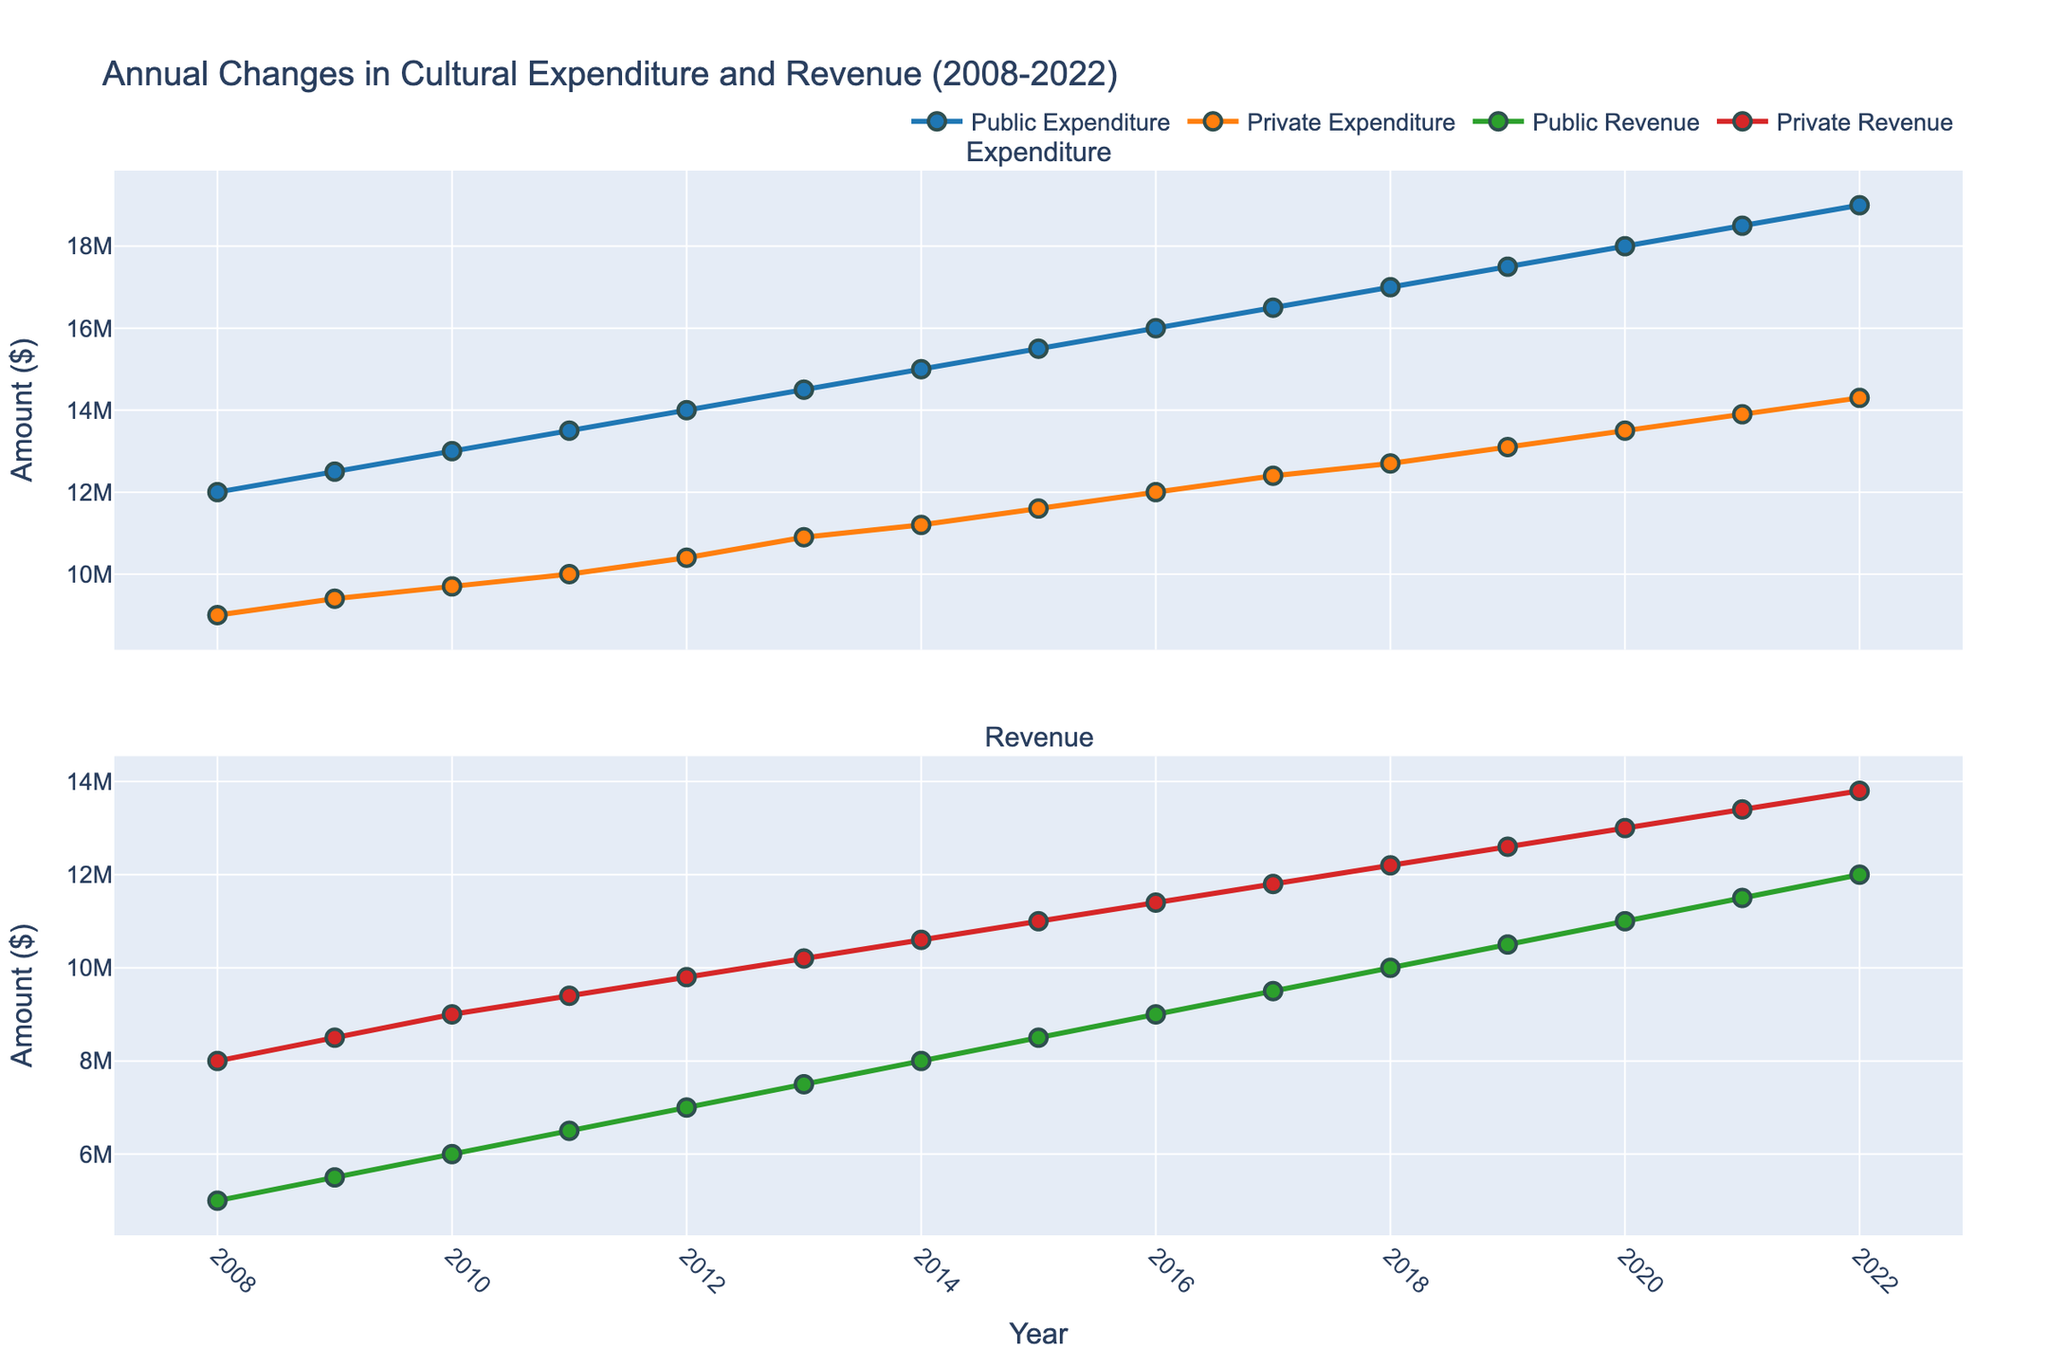What's the title of the plot? The title is located at the top center of the figure.
Answer: Annual Changes in Cultural Expenditure and Revenue (2008-2022) What is the range of years presented in the plot? The x-axis shows the range of years from the first to the last tick marks.
Answer: 2008-2022 Which year had the highest public expenditure? You need to observe the highest point of the blue line in the Expenditure subplot.
Answer: 2022 Which type of expenditure had a higher value in 2013, public or private? Compare the points for public and private expenditures in 2013 in the Expenditure subplot.
Answer: Public How does the trend of private revenue compare from 2008 to 2020? Follow the red line in the Revenue subplot from 2008 to 2020 to see the pattern. It’s generally increasing over the years.
Answer: Increasing What is the average public revenue over the entire period? Sum all the public revenue values from 2008 to 2022 and divide by the number of years. (5000000 + 5500000 + 6000000 + 6500000 + 7000000 + 7500000 + 8000000 + 8500000 + 9000000 + 9500000 + 10000000 + 10500000 + 11000000 + 11500000 + 12000000) / 15 = 85000000 / 15
Answer: 85000000 / 15 = 5666666.67 Which year showed the smallest gap between public and private expenditures? Calculate the difference between public and private expenditures for each year and find the minimum. 2022 has the difference of 19000000 - 14300000 = 4700000, which is the smallest gap.
Answer: 2022 In what year did private revenue exceed public revenue by the largest amount? Compare the differences between private and public revenues for each year and find the largest difference. In 2011, the difference is 9400000 - 6500000 = 2900000, which is the largest gap.
Answer: 2011 What is the general trend in public expenditure over the 15-year period? Follow the blue line in the Expenditure subplot from 2008 to 2022 to recognize the pattern. It’s steadily increasing over the years.
Answer: Increasing 